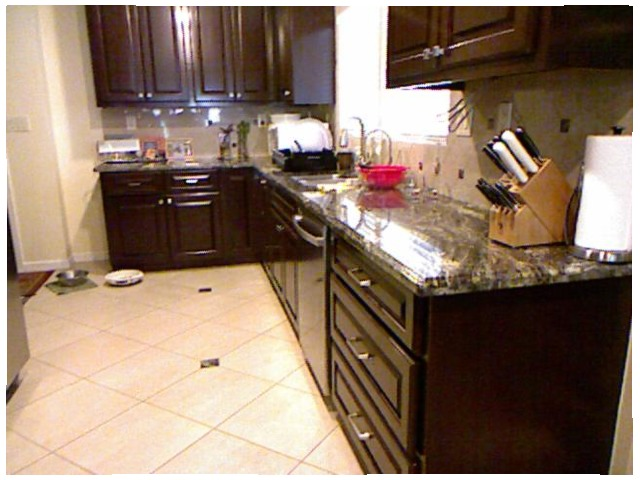<image>
Is there a plate on the floor? Yes. Looking at the image, I can see the plate is positioned on top of the floor, with the floor providing support. Is there a knives in the wood block? Yes. The knives is contained within or inside the wood block, showing a containment relationship. Is the refrigerator next to the dishwasher? No. The refrigerator is not positioned next to the dishwasher. They are located in different areas of the scene. 